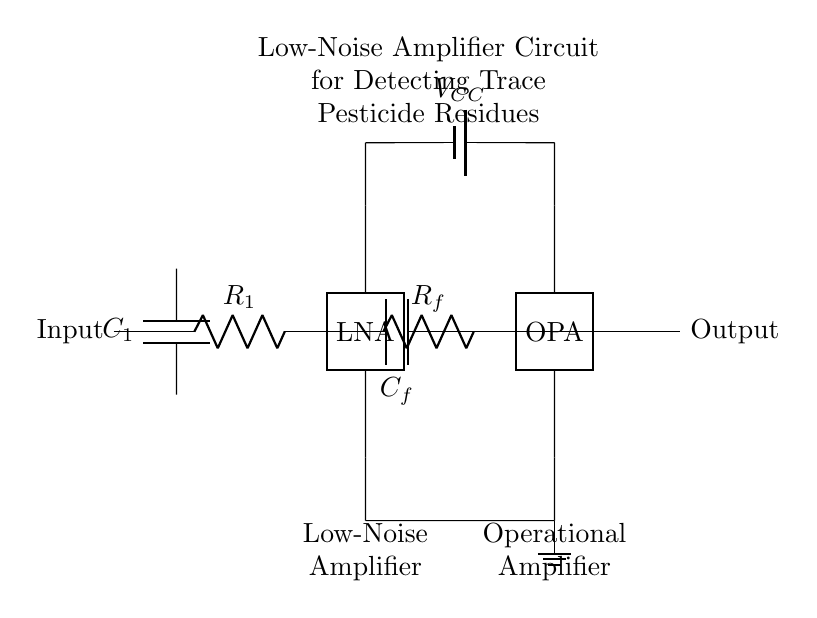What is the type of the first stage amplifier? The first stage of the amplifier circuit is labeled as a "Low-Noise Amplifier," indicating that its primary function is to amplify weak signals while minimizing added noise.
Answer: Low-Noise Amplifier What does the capacitor labeled C1 do in this circuit? The capacitor C1 is typically used for coupling or filtering purposes; it allows AC signals to pass while blocking DC components, which helps in isolating the amplifier stages from DC offsets.
Answer: Coupling What is the purpose of the resistor labeled Rf? The resistor Rf is a feedback resistor that helps determine the gain of the amplifier; it forms a feedback network with the capacitor Cf to stabilize and control the amplification process.
Answer: Feedback How many total amplification stages are present in this circuit? The circuit diagram clearly shows two amplification stages, one identified as a Low-Noise Amplifier and the other as an Operational Amplifier.
Answer: Two What is the power supply voltage indicated in the circuit? The circuit uses a battery labeled VCC for power supply, but the specific voltage value is not provided within the diagram itself; typically, it can range based on application requirements.
Answer: Not specified Which component is responsible for signal conditioning in this circuit? The combination of the first stage Low-Noise Amplifier and the second stage Operational Amplifier plays a key role in signal conditioning, improving the signal quality for detecting pesticide residues.
Answer: Amplifiers What role does the capacitor labeled Cf play in the circuit? The capacitor Cf works in conjunction with the feedback resistor Rf to control the frequency response and gain of the second stage amplifier by affecting the feedback loop.
Answer: Feedback control 